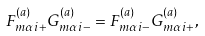Convert formula to latex. <formula><loc_0><loc_0><loc_500><loc_500>F ^ { ( a ) } _ { m \alpha i + } G ^ { ( a ) } _ { m \alpha i - } = F ^ { ( a ) } _ { m \alpha i - } G ^ { ( a ) } _ { m \alpha i + } ,</formula> 